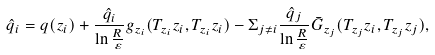Convert formula to latex. <formula><loc_0><loc_0><loc_500><loc_500>\hat { q } _ { i } = q ( z _ { i } ) + \frac { \hat { q } _ { i } } { \ln \frac { R } { \varepsilon } } g _ { z _ { i } } ( T _ { z _ { i } } z _ { i } , T _ { z _ { i } } z _ { i } ) - \Sigma _ { j \neq i } \frac { \hat { q } _ { j } } { \ln \frac { R } { \varepsilon } } \bar { G } _ { z _ { j } } ( T _ { z _ { j } } z _ { i } , T _ { z _ { j } } z _ { j } ) ,</formula> 